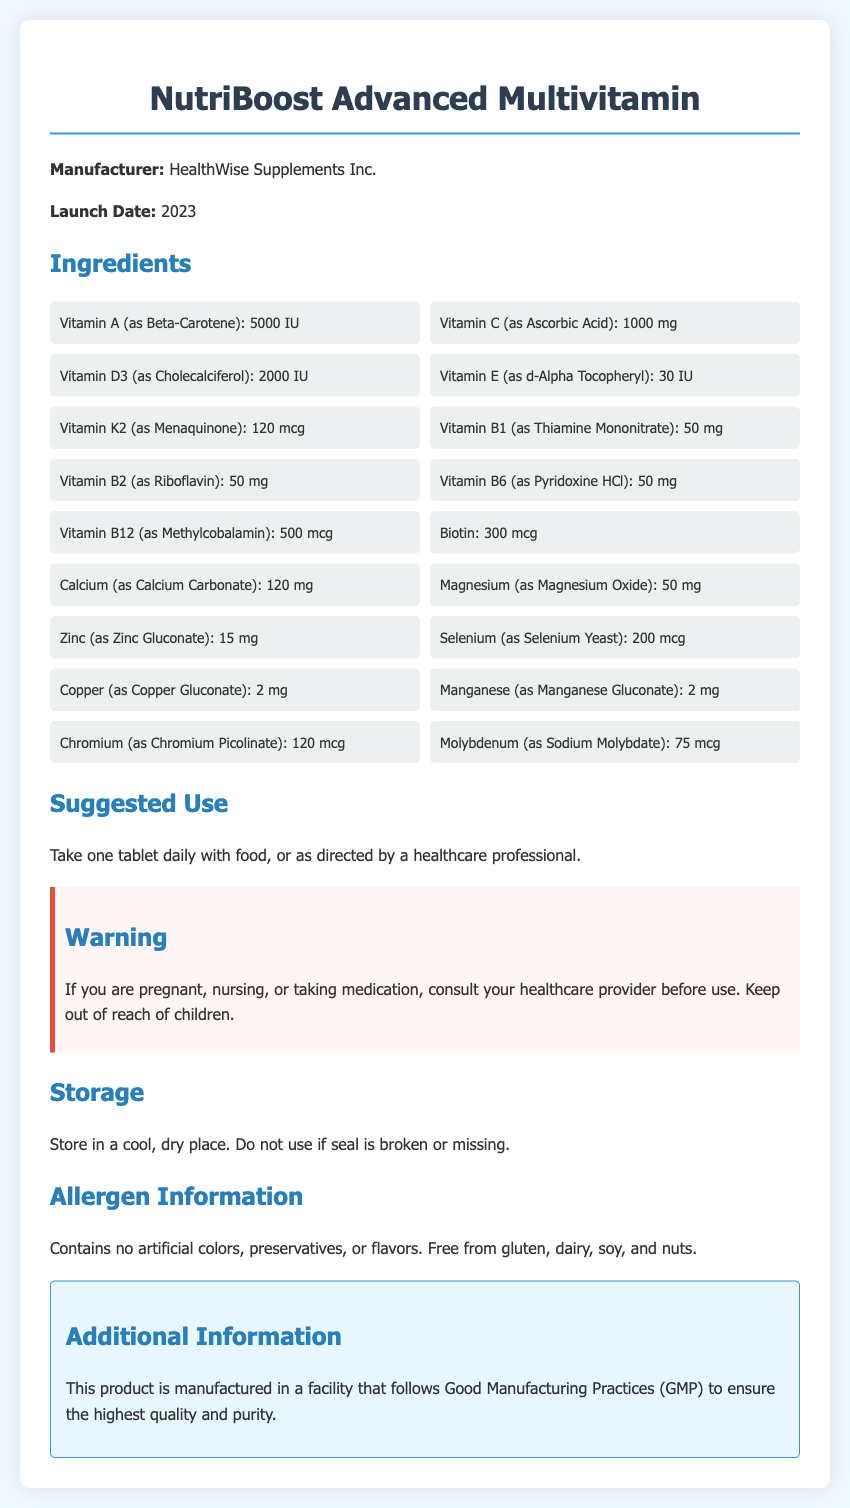what is the name of the product? The document declares the product as "NutriBoost Advanced Multivitamin."
Answer: NutriBoost Advanced Multivitamin who is the manufacturer? The manufacturer of the product is specified as "HealthWise Supplements Inc."
Answer: HealthWise Supplements Inc what is the launch date of the product? The launch date mentioned in the document is 2023.
Answer: 2023 how many milligrams of Vitamin C does the product contain? The amount of Vitamin C listed in the ingredients is 1000 mg.
Answer: 1000 mg what is the suggested use for this product? The document suggests taking one tablet daily with food, or as directed by a healthcare professional.
Answer: One tablet daily with food which vitamin is present as Menaquinone? The document states that Vitamin K2 is present as Menaquinone.
Answer: Vitamin K2 how does this product ensure quality? The document mentions that the product is manufactured following Good Manufacturing Practices (GMP).
Answer: Good Manufacturing Practices (GMP) what should you do if pregnant or nursing? The warning section advises consulting a healthcare provider before use in such cases.
Answer: Consult your healthcare provider does the product contain gluten? The allergen information states that the product is free from gluten.
Answer: Free from gluten what should you do if the seal is broken or missing? The storage section instructs not to use the product if the seal is broken or missing.
Answer: Do not use 